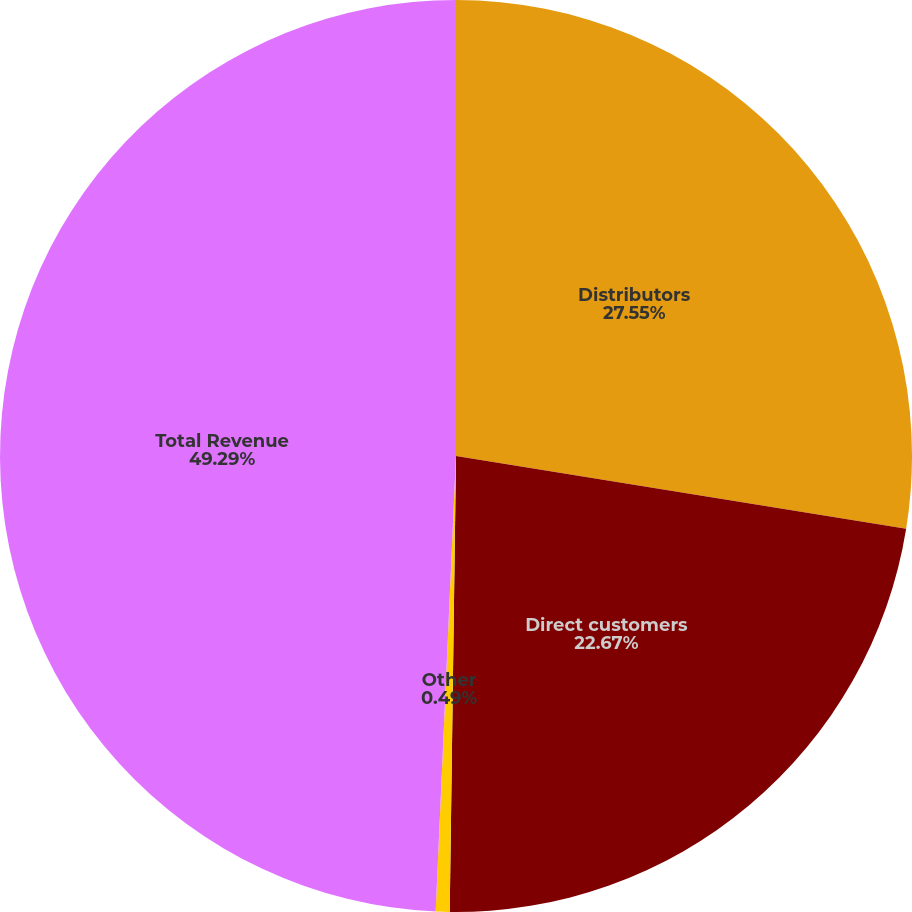Convert chart. <chart><loc_0><loc_0><loc_500><loc_500><pie_chart><fcel>Distributors<fcel>Direct customers<fcel>Other<fcel>Total Revenue<nl><fcel>27.55%<fcel>22.67%<fcel>0.49%<fcel>49.29%<nl></chart> 